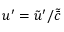Convert formula to latex. <formula><loc_0><loc_0><loc_500><loc_500>u ^ { \prime } = \tilde { u } ^ { \prime } / \tilde { \bar { c } }</formula> 